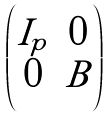Convert formula to latex. <formula><loc_0><loc_0><loc_500><loc_500>\begin{pmatrix} I _ { p } & 0 \\ 0 & B \end{pmatrix}</formula> 